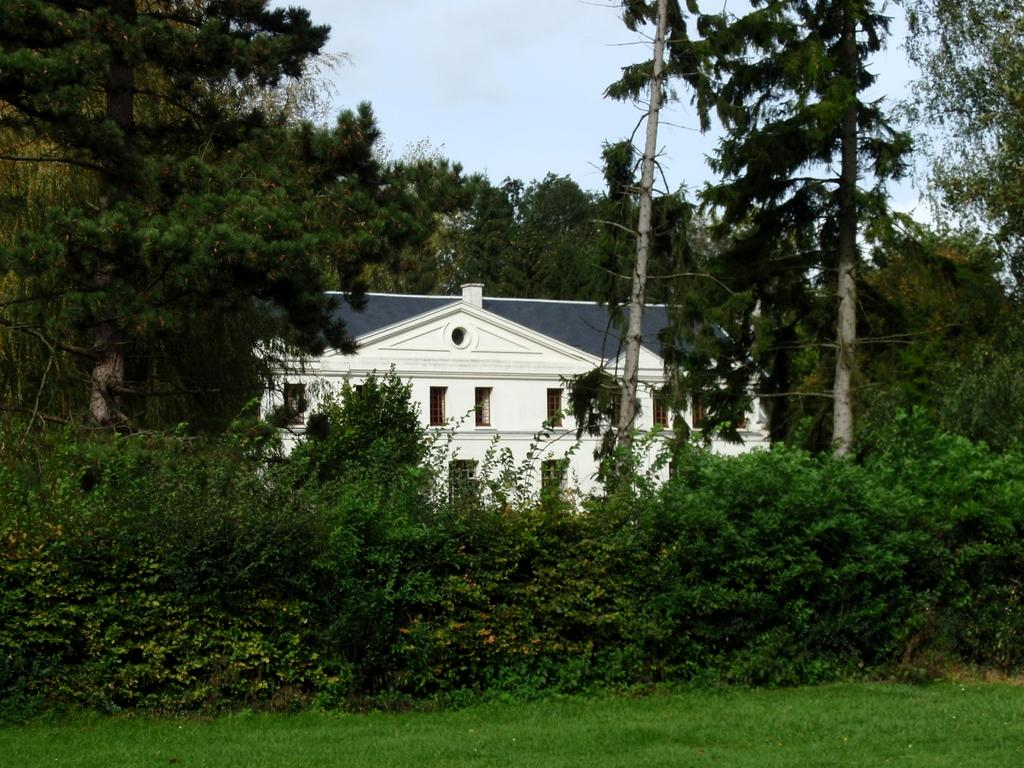What type of vegetation is present in the front of the image? There are plants and trees in the front of the image. What is the ground made of where the plants and trees are located? The plants and trees are on a grassland. What structure can be seen behind the trees? There is a building behind the trees. What part of the natural environment is visible above the building? The sky is visible above the building. How many cows are grazing on the grassland in the image? There are no cows present in the image; it only features plants, trees, a building, and the sky. How does the grandmother contribute to the image? There is no mention of a grandmother in the image or the provided facts. 